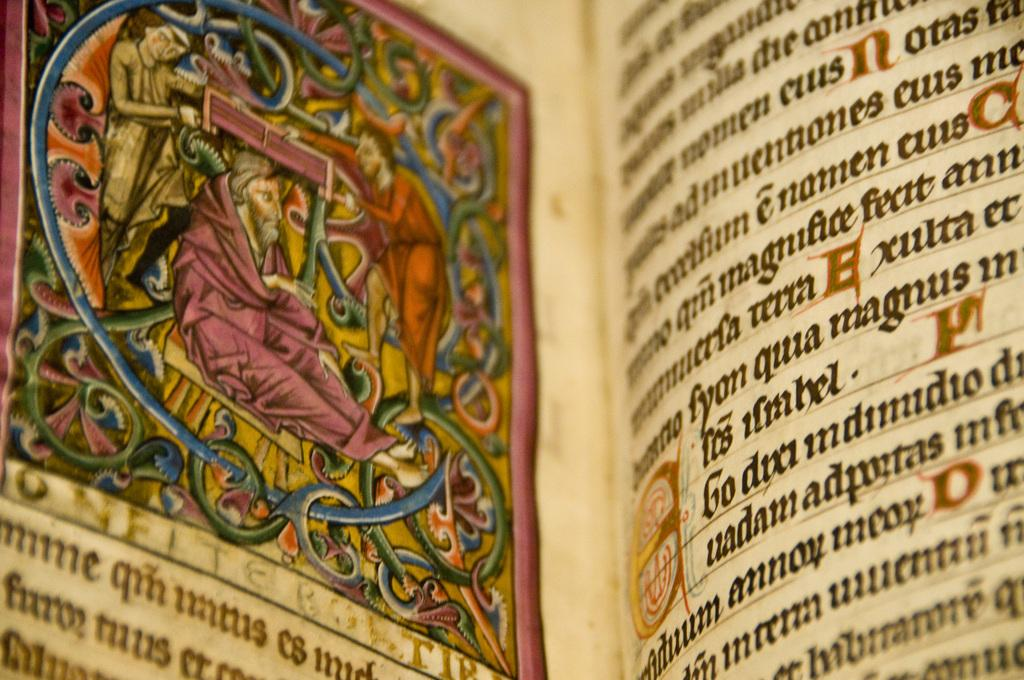<image>
Share a concise interpretation of the image provided. The word magnus can be seen inside of an ancient book 